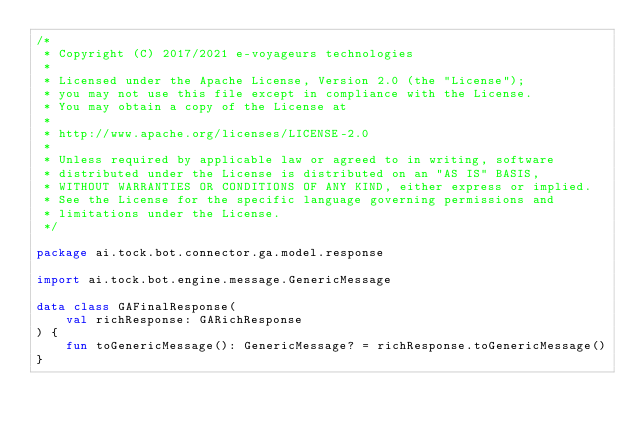<code> <loc_0><loc_0><loc_500><loc_500><_Kotlin_>/*
 * Copyright (C) 2017/2021 e-voyageurs technologies
 *
 * Licensed under the Apache License, Version 2.0 (the "License");
 * you may not use this file except in compliance with the License.
 * You may obtain a copy of the License at
 *
 * http://www.apache.org/licenses/LICENSE-2.0
 *
 * Unless required by applicable law or agreed to in writing, software
 * distributed under the License is distributed on an "AS IS" BASIS,
 * WITHOUT WARRANTIES OR CONDITIONS OF ANY KIND, either express or implied.
 * See the License for the specific language governing permissions and
 * limitations under the License.
 */

package ai.tock.bot.connector.ga.model.response

import ai.tock.bot.engine.message.GenericMessage

data class GAFinalResponse(
    val richResponse: GARichResponse
) {
    fun toGenericMessage(): GenericMessage? = richResponse.toGenericMessage()
}
</code> 